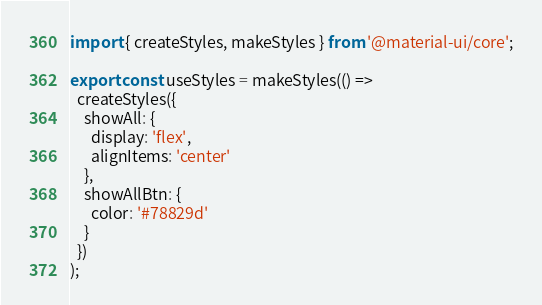<code> <loc_0><loc_0><loc_500><loc_500><_TypeScript_>import { createStyles, makeStyles } from '@material-ui/core';

export const useStyles = makeStyles(() =>
  createStyles({
    showAll: {
      display: 'flex',
      alignItems: 'center'
    },
    showAllBtn: {
      color: '#78829d'
    }
  })
);
</code> 